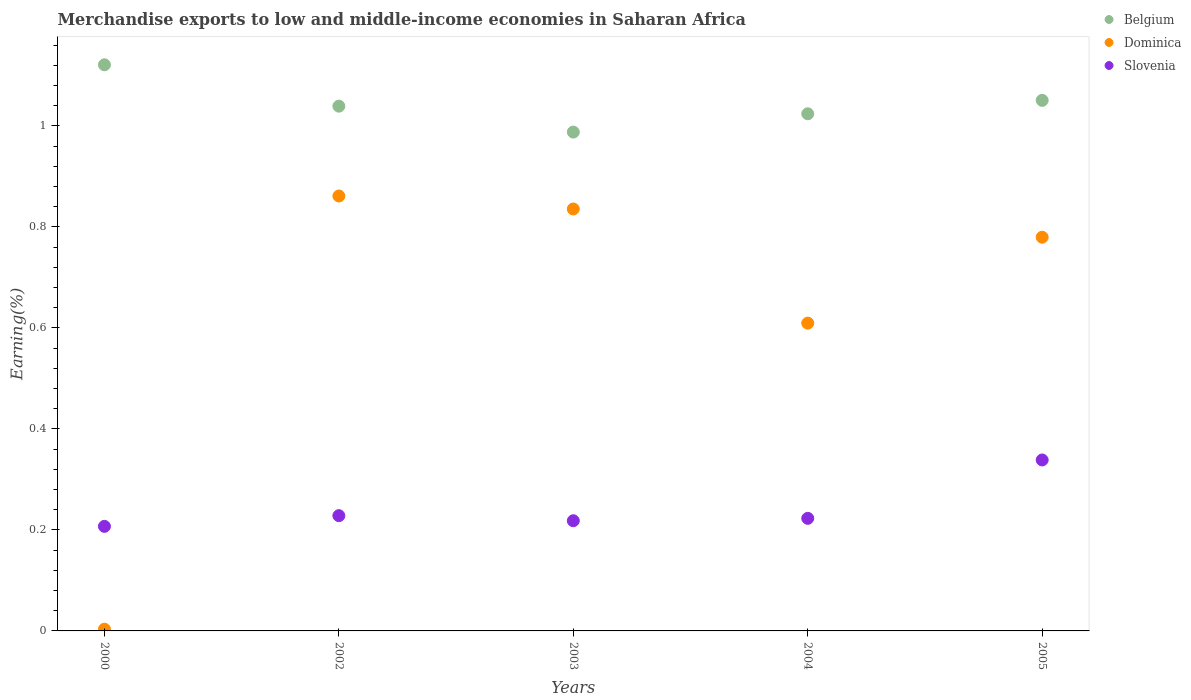How many different coloured dotlines are there?
Give a very brief answer. 3. Is the number of dotlines equal to the number of legend labels?
Your answer should be very brief. Yes. What is the percentage of amount earned from merchandise exports in Belgium in 2005?
Provide a short and direct response. 1.05. Across all years, what is the maximum percentage of amount earned from merchandise exports in Belgium?
Ensure brevity in your answer.  1.12. Across all years, what is the minimum percentage of amount earned from merchandise exports in Belgium?
Make the answer very short. 0.99. In which year was the percentage of amount earned from merchandise exports in Dominica maximum?
Make the answer very short. 2002. In which year was the percentage of amount earned from merchandise exports in Belgium minimum?
Provide a short and direct response. 2003. What is the total percentage of amount earned from merchandise exports in Slovenia in the graph?
Provide a succinct answer. 1.22. What is the difference between the percentage of amount earned from merchandise exports in Slovenia in 2004 and that in 2005?
Give a very brief answer. -0.12. What is the difference between the percentage of amount earned from merchandise exports in Slovenia in 2005 and the percentage of amount earned from merchandise exports in Dominica in 2000?
Your answer should be compact. 0.34. What is the average percentage of amount earned from merchandise exports in Belgium per year?
Make the answer very short. 1.04. In the year 2002, what is the difference between the percentage of amount earned from merchandise exports in Dominica and percentage of amount earned from merchandise exports in Belgium?
Your answer should be very brief. -0.18. What is the ratio of the percentage of amount earned from merchandise exports in Belgium in 2000 to that in 2002?
Offer a very short reply. 1.08. Is the difference between the percentage of amount earned from merchandise exports in Dominica in 2000 and 2003 greater than the difference between the percentage of amount earned from merchandise exports in Belgium in 2000 and 2003?
Your answer should be compact. No. What is the difference between the highest and the second highest percentage of amount earned from merchandise exports in Slovenia?
Your answer should be compact. 0.11. What is the difference between the highest and the lowest percentage of amount earned from merchandise exports in Belgium?
Provide a short and direct response. 0.13. Is it the case that in every year, the sum of the percentage of amount earned from merchandise exports in Slovenia and percentage of amount earned from merchandise exports in Belgium  is greater than the percentage of amount earned from merchandise exports in Dominica?
Ensure brevity in your answer.  Yes. Does the percentage of amount earned from merchandise exports in Dominica monotonically increase over the years?
Offer a terse response. No. Is the percentage of amount earned from merchandise exports in Dominica strictly greater than the percentage of amount earned from merchandise exports in Slovenia over the years?
Ensure brevity in your answer.  No. Is the percentage of amount earned from merchandise exports in Slovenia strictly less than the percentage of amount earned from merchandise exports in Dominica over the years?
Make the answer very short. No. How many dotlines are there?
Provide a succinct answer. 3. How many years are there in the graph?
Ensure brevity in your answer.  5. Are the values on the major ticks of Y-axis written in scientific E-notation?
Offer a very short reply. No. Where does the legend appear in the graph?
Your answer should be very brief. Top right. How many legend labels are there?
Your response must be concise. 3. How are the legend labels stacked?
Your answer should be very brief. Vertical. What is the title of the graph?
Keep it short and to the point. Merchandise exports to low and middle-income economies in Saharan Africa. What is the label or title of the Y-axis?
Provide a short and direct response. Earning(%). What is the Earning(%) of Belgium in 2000?
Give a very brief answer. 1.12. What is the Earning(%) in Dominica in 2000?
Give a very brief answer. 0. What is the Earning(%) of Slovenia in 2000?
Your answer should be compact. 0.21. What is the Earning(%) in Belgium in 2002?
Offer a terse response. 1.04. What is the Earning(%) of Dominica in 2002?
Your answer should be very brief. 0.86. What is the Earning(%) in Slovenia in 2002?
Provide a short and direct response. 0.23. What is the Earning(%) of Belgium in 2003?
Provide a succinct answer. 0.99. What is the Earning(%) of Dominica in 2003?
Make the answer very short. 0.84. What is the Earning(%) of Slovenia in 2003?
Offer a very short reply. 0.22. What is the Earning(%) in Belgium in 2004?
Your answer should be very brief. 1.02. What is the Earning(%) in Dominica in 2004?
Your answer should be compact. 0.61. What is the Earning(%) of Slovenia in 2004?
Offer a terse response. 0.22. What is the Earning(%) of Belgium in 2005?
Offer a terse response. 1.05. What is the Earning(%) of Dominica in 2005?
Provide a short and direct response. 0.78. What is the Earning(%) in Slovenia in 2005?
Offer a terse response. 0.34. Across all years, what is the maximum Earning(%) of Belgium?
Provide a short and direct response. 1.12. Across all years, what is the maximum Earning(%) in Dominica?
Make the answer very short. 0.86. Across all years, what is the maximum Earning(%) of Slovenia?
Your response must be concise. 0.34. Across all years, what is the minimum Earning(%) in Belgium?
Give a very brief answer. 0.99. Across all years, what is the minimum Earning(%) of Dominica?
Offer a very short reply. 0. Across all years, what is the minimum Earning(%) in Slovenia?
Keep it short and to the point. 0.21. What is the total Earning(%) in Belgium in the graph?
Offer a very short reply. 5.22. What is the total Earning(%) of Dominica in the graph?
Offer a very short reply. 3.09. What is the total Earning(%) of Slovenia in the graph?
Your response must be concise. 1.22. What is the difference between the Earning(%) of Belgium in 2000 and that in 2002?
Provide a succinct answer. 0.08. What is the difference between the Earning(%) of Dominica in 2000 and that in 2002?
Your answer should be compact. -0.86. What is the difference between the Earning(%) in Slovenia in 2000 and that in 2002?
Your answer should be compact. -0.02. What is the difference between the Earning(%) in Belgium in 2000 and that in 2003?
Offer a very short reply. 0.13. What is the difference between the Earning(%) of Dominica in 2000 and that in 2003?
Keep it short and to the point. -0.83. What is the difference between the Earning(%) of Slovenia in 2000 and that in 2003?
Give a very brief answer. -0.01. What is the difference between the Earning(%) of Belgium in 2000 and that in 2004?
Offer a very short reply. 0.1. What is the difference between the Earning(%) of Dominica in 2000 and that in 2004?
Make the answer very short. -0.61. What is the difference between the Earning(%) in Slovenia in 2000 and that in 2004?
Keep it short and to the point. -0.02. What is the difference between the Earning(%) of Belgium in 2000 and that in 2005?
Make the answer very short. 0.07. What is the difference between the Earning(%) of Dominica in 2000 and that in 2005?
Offer a terse response. -0.78. What is the difference between the Earning(%) in Slovenia in 2000 and that in 2005?
Give a very brief answer. -0.13. What is the difference between the Earning(%) of Belgium in 2002 and that in 2003?
Give a very brief answer. 0.05. What is the difference between the Earning(%) in Dominica in 2002 and that in 2003?
Ensure brevity in your answer.  0.03. What is the difference between the Earning(%) in Slovenia in 2002 and that in 2003?
Offer a terse response. 0.01. What is the difference between the Earning(%) of Belgium in 2002 and that in 2004?
Offer a very short reply. 0.02. What is the difference between the Earning(%) of Dominica in 2002 and that in 2004?
Ensure brevity in your answer.  0.25. What is the difference between the Earning(%) of Slovenia in 2002 and that in 2004?
Give a very brief answer. 0.01. What is the difference between the Earning(%) of Belgium in 2002 and that in 2005?
Make the answer very short. -0.01. What is the difference between the Earning(%) of Dominica in 2002 and that in 2005?
Ensure brevity in your answer.  0.08. What is the difference between the Earning(%) in Slovenia in 2002 and that in 2005?
Offer a terse response. -0.11. What is the difference between the Earning(%) of Belgium in 2003 and that in 2004?
Your answer should be compact. -0.04. What is the difference between the Earning(%) in Dominica in 2003 and that in 2004?
Offer a terse response. 0.23. What is the difference between the Earning(%) in Slovenia in 2003 and that in 2004?
Ensure brevity in your answer.  -0. What is the difference between the Earning(%) of Belgium in 2003 and that in 2005?
Give a very brief answer. -0.06. What is the difference between the Earning(%) of Dominica in 2003 and that in 2005?
Make the answer very short. 0.06. What is the difference between the Earning(%) of Slovenia in 2003 and that in 2005?
Keep it short and to the point. -0.12. What is the difference between the Earning(%) in Belgium in 2004 and that in 2005?
Provide a short and direct response. -0.03. What is the difference between the Earning(%) in Dominica in 2004 and that in 2005?
Ensure brevity in your answer.  -0.17. What is the difference between the Earning(%) of Slovenia in 2004 and that in 2005?
Provide a succinct answer. -0.12. What is the difference between the Earning(%) of Belgium in 2000 and the Earning(%) of Dominica in 2002?
Provide a short and direct response. 0.26. What is the difference between the Earning(%) in Belgium in 2000 and the Earning(%) in Slovenia in 2002?
Your answer should be compact. 0.89. What is the difference between the Earning(%) of Dominica in 2000 and the Earning(%) of Slovenia in 2002?
Provide a succinct answer. -0.22. What is the difference between the Earning(%) in Belgium in 2000 and the Earning(%) in Dominica in 2003?
Give a very brief answer. 0.29. What is the difference between the Earning(%) in Belgium in 2000 and the Earning(%) in Slovenia in 2003?
Give a very brief answer. 0.9. What is the difference between the Earning(%) in Dominica in 2000 and the Earning(%) in Slovenia in 2003?
Keep it short and to the point. -0.21. What is the difference between the Earning(%) in Belgium in 2000 and the Earning(%) in Dominica in 2004?
Keep it short and to the point. 0.51. What is the difference between the Earning(%) of Belgium in 2000 and the Earning(%) of Slovenia in 2004?
Offer a very short reply. 0.9. What is the difference between the Earning(%) in Dominica in 2000 and the Earning(%) in Slovenia in 2004?
Offer a very short reply. -0.22. What is the difference between the Earning(%) of Belgium in 2000 and the Earning(%) of Dominica in 2005?
Provide a short and direct response. 0.34. What is the difference between the Earning(%) in Belgium in 2000 and the Earning(%) in Slovenia in 2005?
Make the answer very short. 0.78. What is the difference between the Earning(%) of Dominica in 2000 and the Earning(%) of Slovenia in 2005?
Offer a terse response. -0.34. What is the difference between the Earning(%) in Belgium in 2002 and the Earning(%) in Dominica in 2003?
Make the answer very short. 0.2. What is the difference between the Earning(%) in Belgium in 2002 and the Earning(%) in Slovenia in 2003?
Provide a succinct answer. 0.82. What is the difference between the Earning(%) of Dominica in 2002 and the Earning(%) of Slovenia in 2003?
Your answer should be very brief. 0.64. What is the difference between the Earning(%) in Belgium in 2002 and the Earning(%) in Dominica in 2004?
Your answer should be very brief. 0.43. What is the difference between the Earning(%) in Belgium in 2002 and the Earning(%) in Slovenia in 2004?
Provide a short and direct response. 0.82. What is the difference between the Earning(%) of Dominica in 2002 and the Earning(%) of Slovenia in 2004?
Ensure brevity in your answer.  0.64. What is the difference between the Earning(%) of Belgium in 2002 and the Earning(%) of Dominica in 2005?
Give a very brief answer. 0.26. What is the difference between the Earning(%) in Belgium in 2002 and the Earning(%) in Slovenia in 2005?
Give a very brief answer. 0.7. What is the difference between the Earning(%) in Dominica in 2002 and the Earning(%) in Slovenia in 2005?
Provide a succinct answer. 0.52. What is the difference between the Earning(%) in Belgium in 2003 and the Earning(%) in Dominica in 2004?
Your answer should be compact. 0.38. What is the difference between the Earning(%) in Belgium in 2003 and the Earning(%) in Slovenia in 2004?
Make the answer very short. 0.76. What is the difference between the Earning(%) of Dominica in 2003 and the Earning(%) of Slovenia in 2004?
Offer a very short reply. 0.61. What is the difference between the Earning(%) of Belgium in 2003 and the Earning(%) of Dominica in 2005?
Your response must be concise. 0.21. What is the difference between the Earning(%) in Belgium in 2003 and the Earning(%) in Slovenia in 2005?
Provide a short and direct response. 0.65. What is the difference between the Earning(%) of Dominica in 2003 and the Earning(%) of Slovenia in 2005?
Offer a very short reply. 0.5. What is the difference between the Earning(%) in Belgium in 2004 and the Earning(%) in Dominica in 2005?
Keep it short and to the point. 0.24. What is the difference between the Earning(%) of Belgium in 2004 and the Earning(%) of Slovenia in 2005?
Offer a terse response. 0.69. What is the difference between the Earning(%) of Dominica in 2004 and the Earning(%) of Slovenia in 2005?
Give a very brief answer. 0.27. What is the average Earning(%) in Belgium per year?
Your answer should be compact. 1.04. What is the average Earning(%) of Dominica per year?
Provide a short and direct response. 0.62. What is the average Earning(%) in Slovenia per year?
Ensure brevity in your answer.  0.24. In the year 2000, what is the difference between the Earning(%) in Belgium and Earning(%) in Dominica?
Your answer should be very brief. 1.12. In the year 2000, what is the difference between the Earning(%) of Belgium and Earning(%) of Slovenia?
Provide a short and direct response. 0.91. In the year 2000, what is the difference between the Earning(%) of Dominica and Earning(%) of Slovenia?
Keep it short and to the point. -0.2. In the year 2002, what is the difference between the Earning(%) in Belgium and Earning(%) in Dominica?
Provide a succinct answer. 0.18. In the year 2002, what is the difference between the Earning(%) in Belgium and Earning(%) in Slovenia?
Your answer should be very brief. 0.81. In the year 2002, what is the difference between the Earning(%) of Dominica and Earning(%) of Slovenia?
Keep it short and to the point. 0.63. In the year 2003, what is the difference between the Earning(%) in Belgium and Earning(%) in Dominica?
Offer a terse response. 0.15. In the year 2003, what is the difference between the Earning(%) of Belgium and Earning(%) of Slovenia?
Provide a short and direct response. 0.77. In the year 2003, what is the difference between the Earning(%) of Dominica and Earning(%) of Slovenia?
Give a very brief answer. 0.62. In the year 2004, what is the difference between the Earning(%) in Belgium and Earning(%) in Dominica?
Offer a very short reply. 0.41. In the year 2004, what is the difference between the Earning(%) in Belgium and Earning(%) in Slovenia?
Provide a succinct answer. 0.8. In the year 2004, what is the difference between the Earning(%) in Dominica and Earning(%) in Slovenia?
Ensure brevity in your answer.  0.39. In the year 2005, what is the difference between the Earning(%) of Belgium and Earning(%) of Dominica?
Provide a short and direct response. 0.27. In the year 2005, what is the difference between the Earning(%) of Belgium and Earning(%) of Slovenia?
Provide a succinct answer. 0.71. In the year 2005, what is the difference between the Earning(%) of Dominica and Earning(%) of Slovenia?
Offer a terse response. 0.44. What is the ratio of the Earning(%) in Belgium in 2000 to that in 2002?
Make the answer very short. 1.08. What is the ratio of the Earning(%) in Dominica in 2000 to that in 2002?
Keep it short and to the point. 0. What is the ratio of the Earning(%) of Slovenia in 2000 to that in 2002?
Provide a succinct answer. 0.91. What is the ratio of the Earning(%) in Belgium in 2000 to that in 2003?
Make the answer very short. 1.13. What is the ratio of the Earning(%) of Dominica in 2000 to that in 2003?
Your answer should be compact. 0. What is the ratio of the Earning(%) in Slovenia in 2000 to that in 2003?
Offer a terse response. 0.95. What is the ratio of the Earning(%) of Belgium in 2000 to that in 2004?
Provide a succinct answer. 1.09. What is the ratio of the Earning(%) in Dominica in 2000 to that in 2004?
Offer a terse response. 0.01. What is the ratio of the Earning(%) of Slovenia in 2000 to that in 2004?
Your answer should be very brief. 0.93. What is the ratio of the Earning(%) of Belgium in 2000 to that in 2005?
Keep it short and to the point. 1.07. What is the ratio of the Earning(%) of Dominica in 2000 to that in 2005?
Provide a short and direct response. 0. What is the ratio of the Earning(%) of Slovenia in 2000 to that in 2005?
Ensure brevity in your answer.  0.61. What is the ratio of the Earning(%) in Belgium in 2002 to that in 2003?
Your answer should be compact. 1.05. What is the ratio of the Earning(%) in Dominica in 2002 to that in 2003?
Provide a short and direct response. 1.03. What is the ratio of the Earning(%) of Slovenia in 2002 to that in 2003?
Offer a terse response. 1.05. What is the ratio of the Earning(%) in Belgium in 2002 to that in 2004?
Provide a succinct answer. 1.01. What is the ratio of the Earning(%) of Dominica in 2002 to that in 2004?
Your answer should be compact. 1.41. What is the ratio of the Earning(%) in Slovenia in 2002 to that in 2004?
Offer a terse response. 1.02. What is the ratio of the Earning(%) of Dominica in 2002 to that in 2005?
Provide a succinct answer. 1.1. What is the ratio of the Earning(%) of Slovenia in 2002 to that in 2005?
Offer a very short reply. 0.67. What is the ratio of the Earning(%) of Belgium in 2003 to that in 2004?
Give a very brief answer. 0.96. What is the ratio of the Earning(%) in Dominica in 2003 to that in 2004?
Your response must be concise. 1.37. What is the ratio of the Earning(%) of Slovenia in 2003 to that in 2004?
Make the answer very short. 0.98. What is the ratio of the Earning(%) of Belgium in 2003 to that in 2005?
Provide a succinct answer. 0.94. What is the ratio of the Earning(%) of Dominica in 2003 to that in 2005?
Provide a short and direct response. 1.07. What is the ratio of the Earning(%) in Slovenia in 2003 to that in 2005?
Provide a succinct answer. 0.64. What is the ratio of the Earning(%) of Belgium in 2004 to that in 2005?
Offer a very short reply. 0.97. What is the ratio of the Earning(%) of Dominica in 2004 to that in 2005?
Offer a terse response. 0.78. What is the ratio of the Earning(%) of Slovenia in 2004 to that in 2005?
Give a very brief answer. 0.66. What is the difference between the highest and the second highest Earning(%) of Belgium?
Provide a succinct answer. 0.07. What is the difference between the highest and the second highest Earning(%) of Dominica?
Offer a terse response. 0.03. What is the difference between the highest and the second highest Earning(%) in Slovenia?
Give a very brief answer. 0.11. What is the difference between the highest and the lowest Earning(%) of Belgium?
Your answer should be compact. 0.13. What is the difference between the highest and the lowest Earning(%) of Dominica?
Keep it short and to the point. 0.86. What is the difference between the highest and the lowest Earning(%) of Slovenia?
Provide a succinct answer. 0.13. 